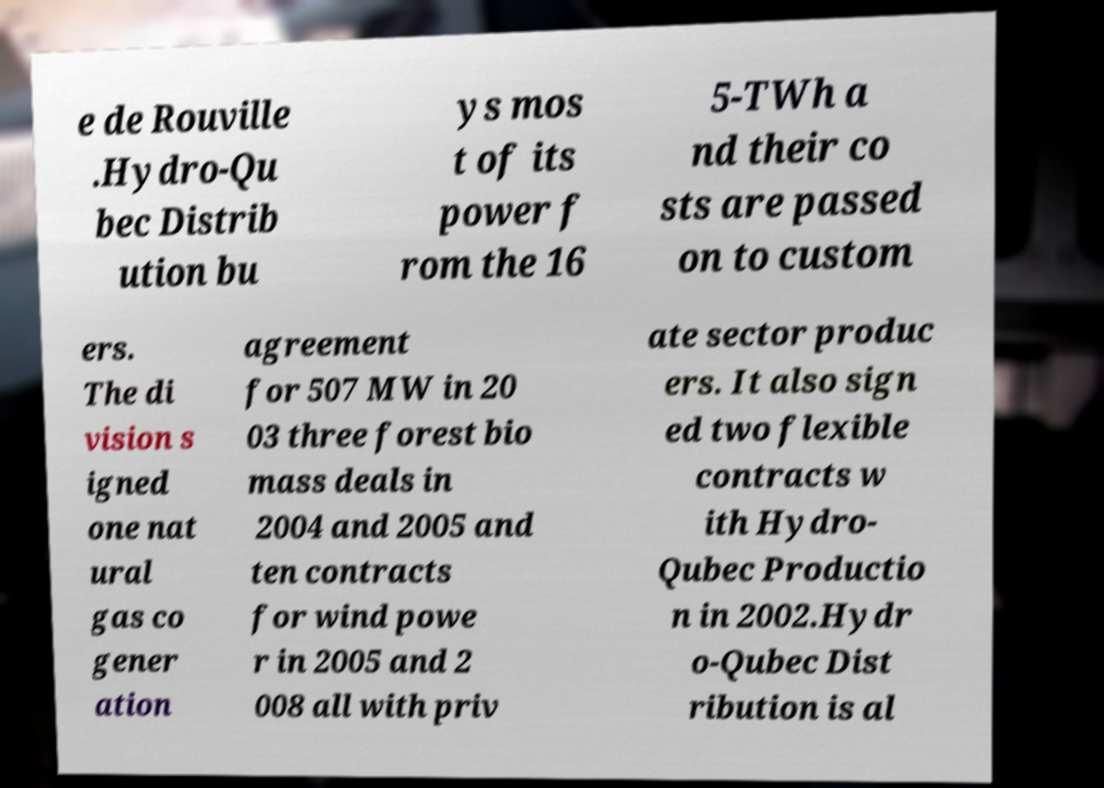Please read and relay the text visible in this image. What does it say? e de Rouville .Hydro-Qu bec Distrib ution bu ys mos t of its power f rom the 16 5-TWh a nd their co sts are passed on to custom ers. The di vision s igned one nat ural gas co gener ation agreement for 507 MW in 20 03 three forest bio mass deals in 2004 and 2005 and ten contracts for wind powe r in 2005 and 2 008 all with priv ate sector produc ers. It also sign ed two flexible contracts w ith Hydro- Qubec Productio n in 2002.Hydr o-Qubec Dist ribution is al 